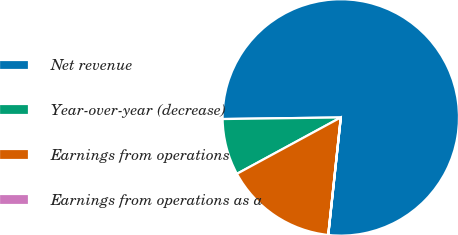Convert chart. <chart><loc_0><loc_0><loc_500><loc_500><pie_chart><fcel>Net revenue<fcel>Year-over-year (decrease)<fcel>Earnings from operations<fcel>Earnings from operations as a<nl><fcel>76.91%<fcel>7.7%<fcel>15.39%<fcel>0.01%<nl></chart> 